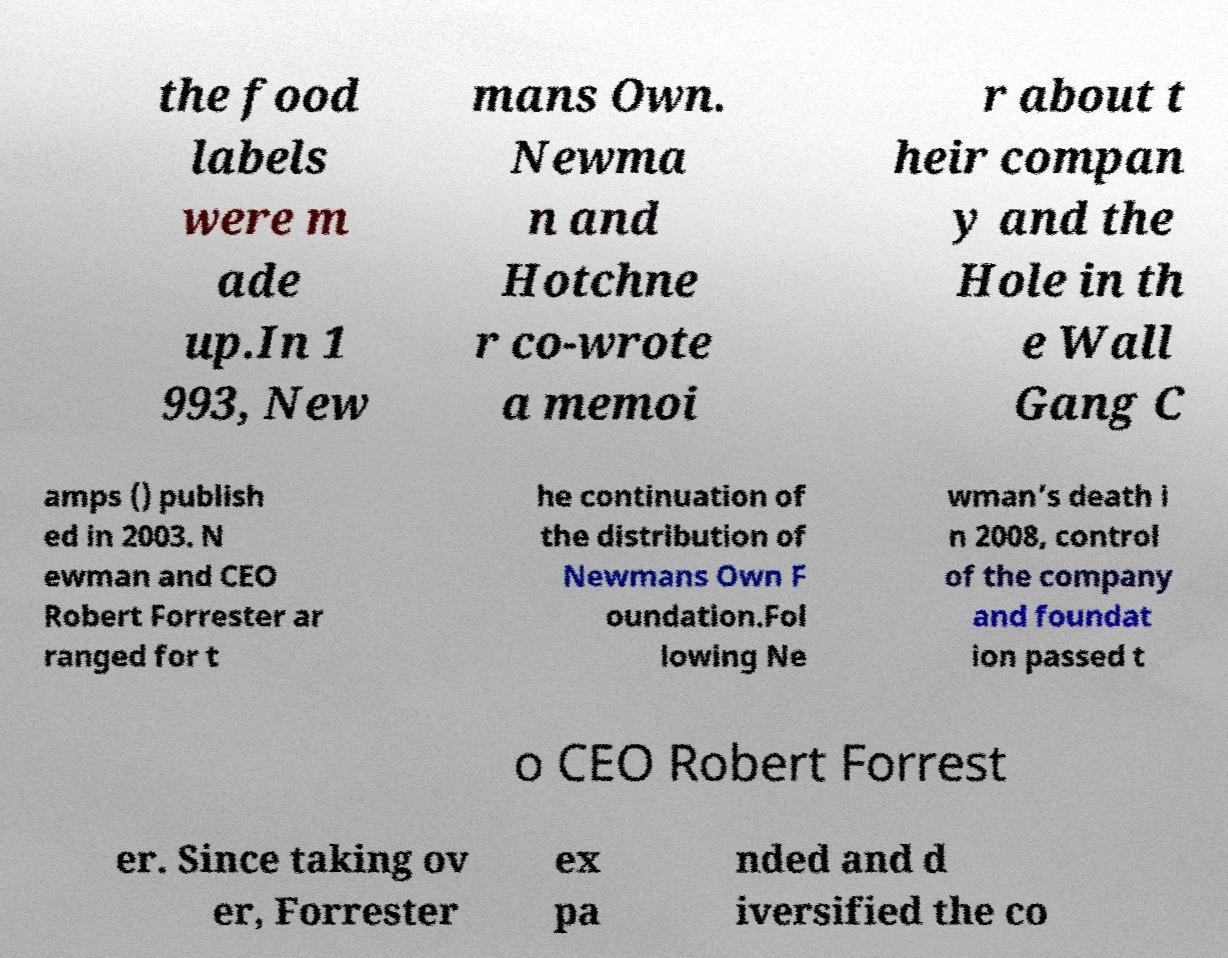Could you extract and type out the text from this image? the food labels were m ade up.In 1 993, New mans Own. Newma n and Hotchne r co-wrote a memoi r about t heir compan y and the Hole in th e Wall Gang C amps () publish ed in 2003. N ewman and CEO Robert Forrester ar ranged for t he continuation of the distribution of Newmans Own F oundation.Fol lowing Ne wman’s death i n 2008, control of the company and foundat ion passed t o CEO Robert Forrest er. Since taking ov er, Forrester ex pa nded and d iversified the co 